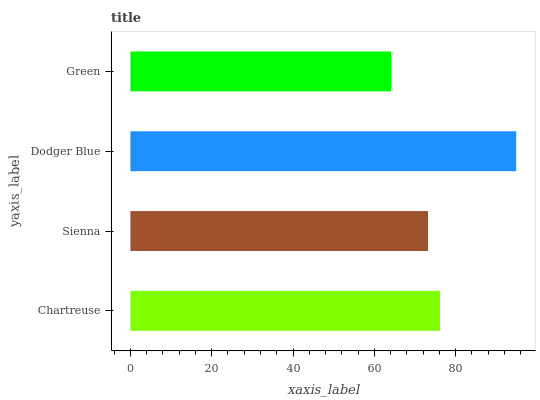Is Green the minimum?
Answer yes or no. Yes. Is Dodger Blue the maximum?
Answer yes or no. Yes. Is Sienna the minimum?
Answer yes or no. No. Is Sienna the maximum?
Answer yes or no. No. Is Chartreuse greater than Sienna?
Answer yes or no. Yes. Is Sienna less than Chartreuse?
Answer yes or no. Yes. Is Sienna greater than Chartreuse?
Answer yes or no. No. Is Chartreuse less than Sienna?
Answer yes or no. No. Is Chartreuse the high median?
Answer yes or no. Yes. Is Sienna the low median?
Answer yes or no. Yes. Is Sienna the high median?
Answer yes or no. No. Is Green the low median?
Answer yes or no. No. 